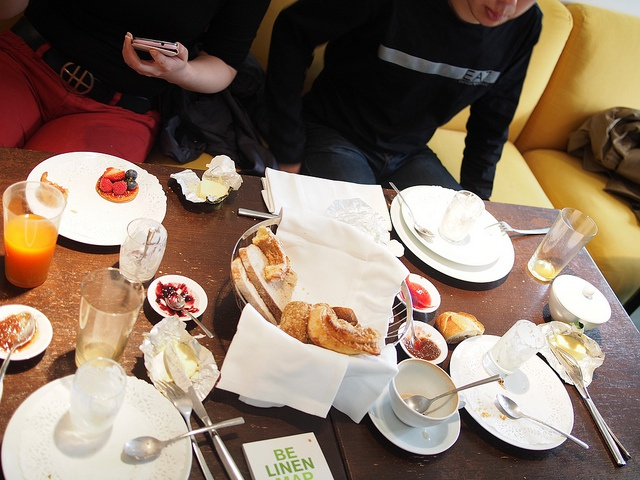Describe the objects in this image and their specific colors. I can see dining table in maroon, white, black, and tan tones, people in maroon, black, gray, and tan tones, people in maroon, black, brown, and gray tones, couch in maroon, khaki, olive, and tan tones, and bowl in maroon, lightgray, tan, and brown tones in this image. 